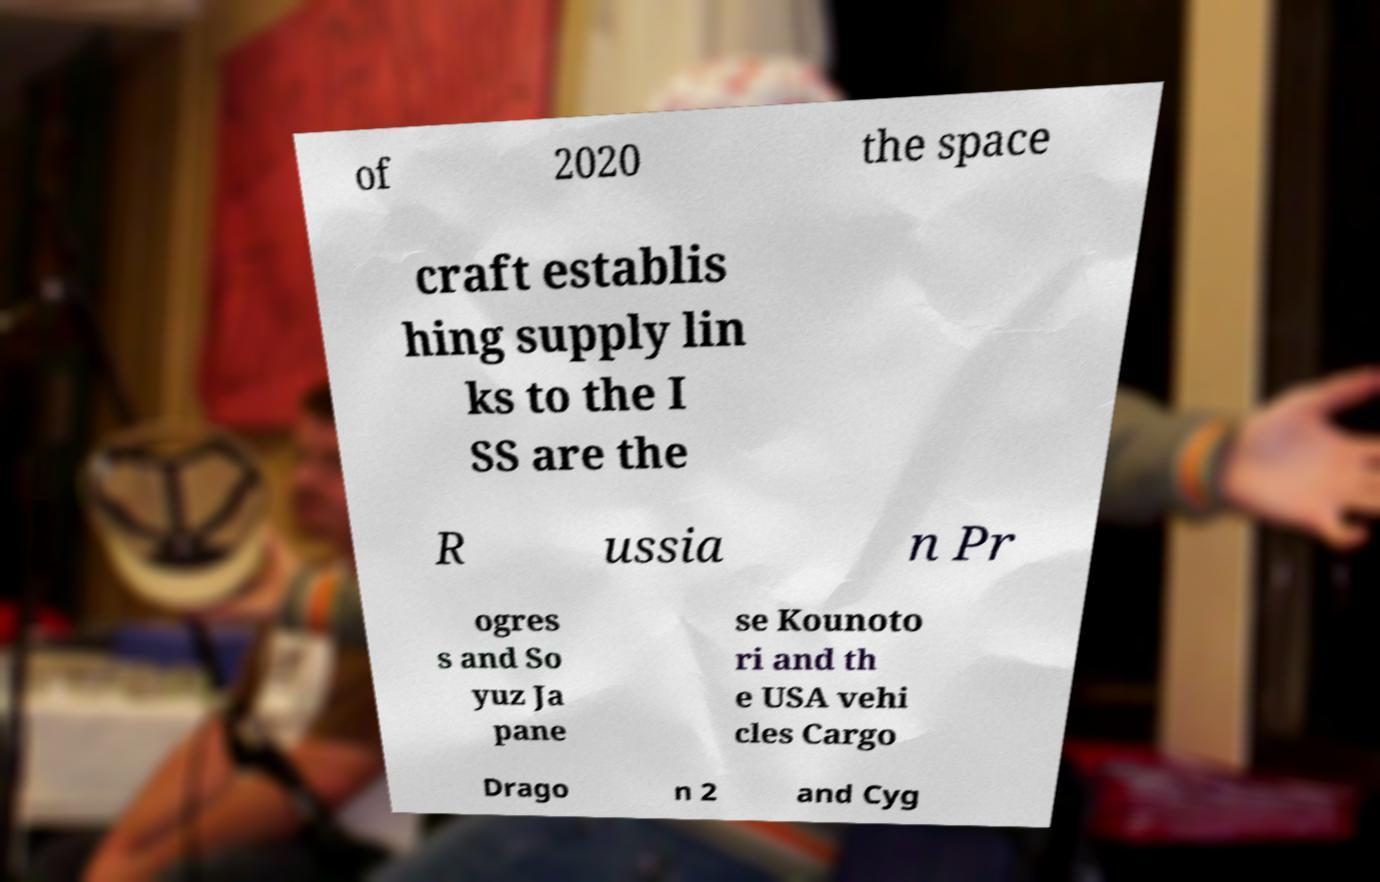Could you extract and type out the text from this image? of 2020 the space craft establis hing supply lin ks to the I SS are the R ussia n Pr ogres s and So yuz Ja pane se Kounoto ri and th e USA vehi cles Cargo Drago n 2 and Cyg 